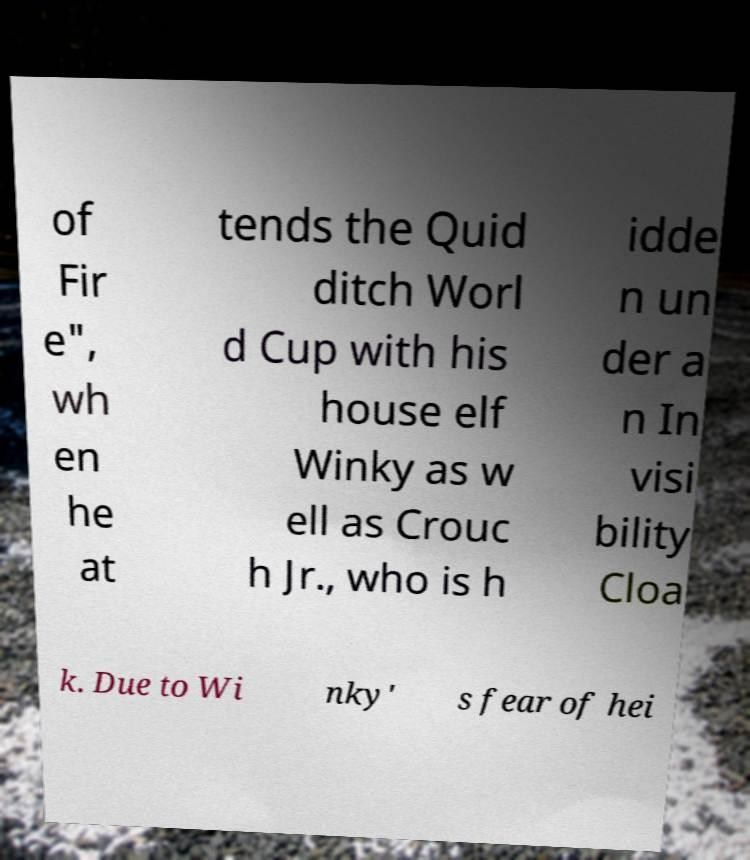Please read and relay the text visible in this image. What does it say? of Fir e", wh en he at tends the Quid ditch Worl d Cup with his house elf Winky as w ell as Crouc h Jr., who is h idde n un der a n In visi bility Cloa k. Due to Wi nky' s fear of hei 